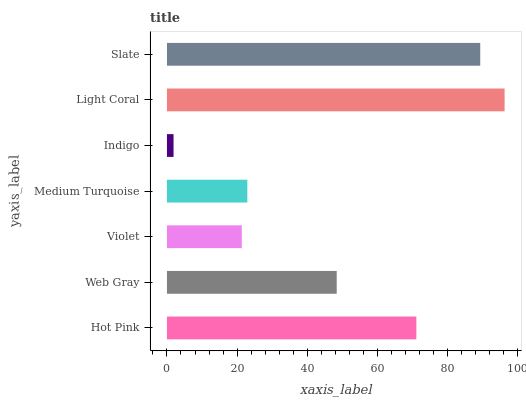Is Indigo the minimum?
Answer yes or no. Yes. Is Light Coral the maximum?
Answer yes or no. Yes. Is Web Gray the minimum?
Answer yes or no. No. Is Web Gray the maximum?
Answer yes or no. No. Is Hot Pink greater than Web Gray?
Answer yes or no. Yes. Is Web Gray less than Hot Pink?
Answer yes or no. Yes. Is Web Gray greater than Hot Pink?
Answer yes or no. No. Is Hot Pink less than Web Gray?
Answer yes or no. No. Is Web Gray the high median?
Answer yes or no. Yes. Is Web Gray the low median?
Answer yes or no. Yes. Is Medium Turquoise the high median?
Answer yes or no. No. Is Medium Turquoise the low median?
Answer yes or no. No. 